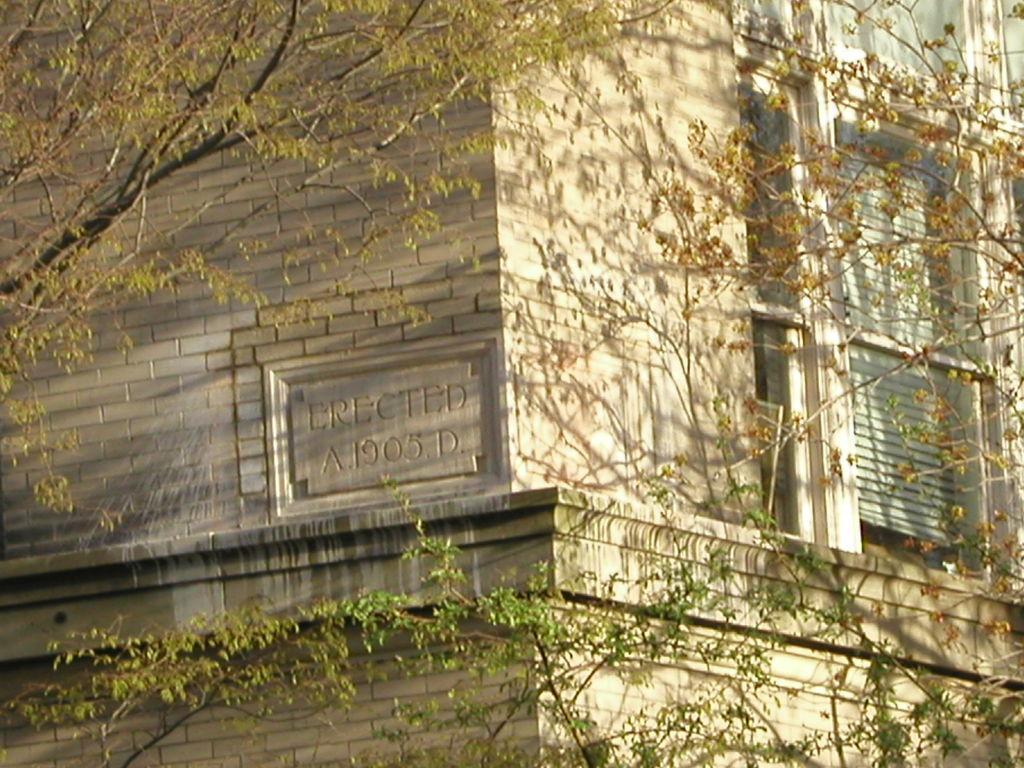Can you describe this image briefly? In this image, we can see a building with some text and the window blind. There are a few trees. 